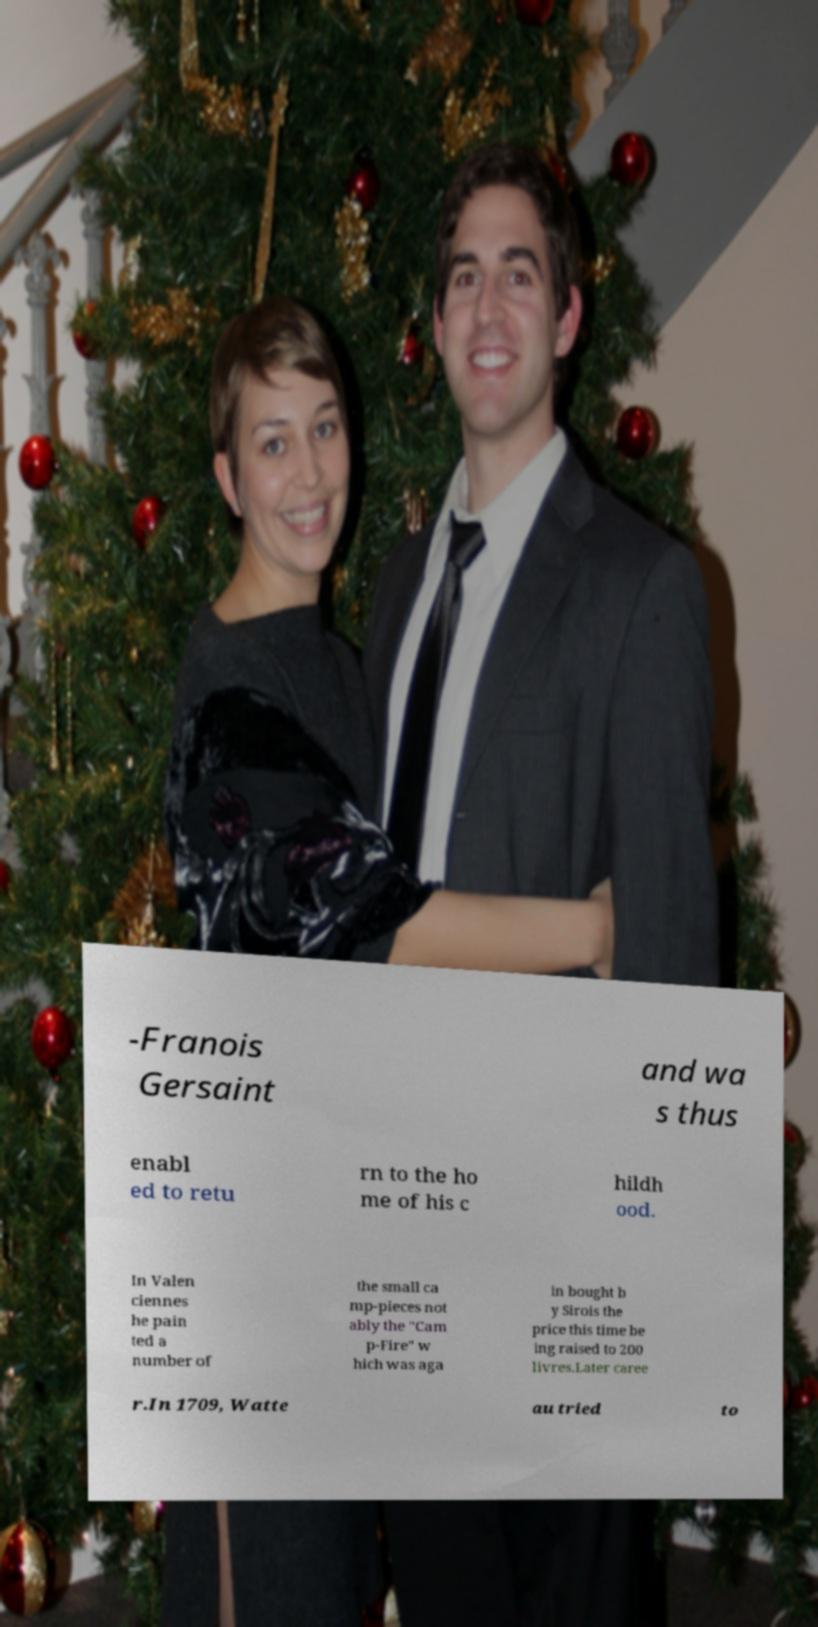Could you assist in decoding the text presented in this image and type it out clearly? -Franois Gersaint and wa s thus enabl ed to retu rn to the ho me of his c hildh ood. In Valen ciennes he pain ted a number of the small ca mp-pieces not ably the "Cam p-Fire" w hich was aga in bought b y Sirois the price this time be ing raised to 200 livres.Later caree r.In 1709, Watte au tried to 